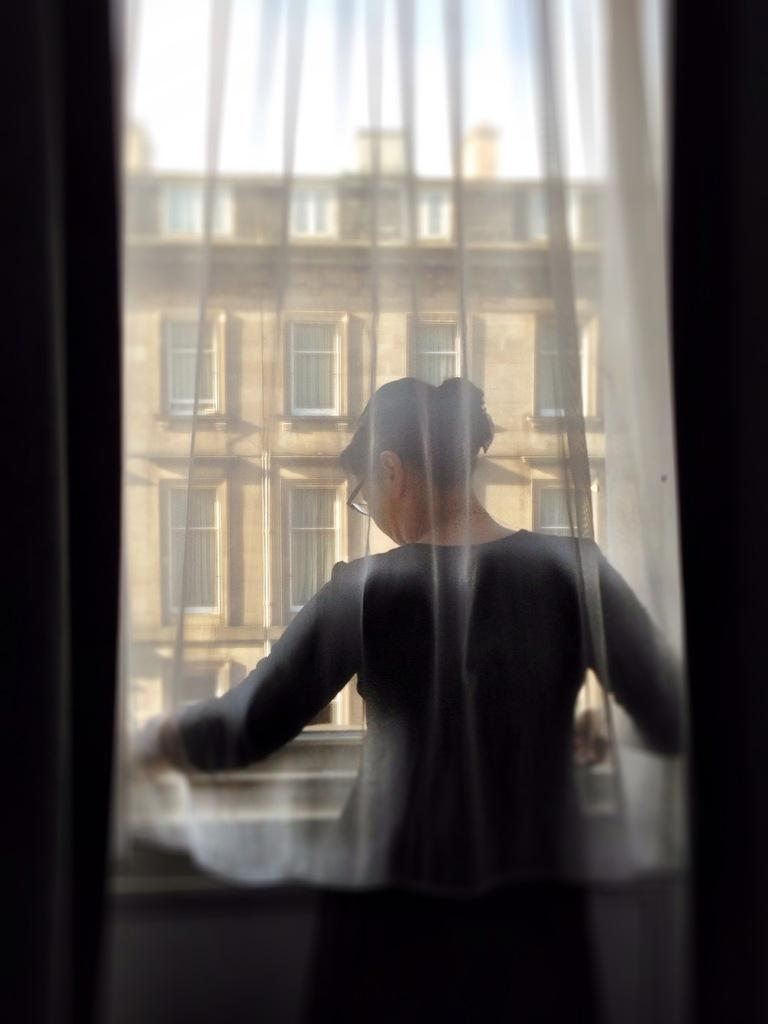Who or what is the main subject in the image? There is a person in the image. Where is the person located in relation to other elements in the image? The person is in front of a window. What can be seen in the middle of the image? There is a building in the middle of the image. Where is the sink located in the image? There is no sink present in the image. What type of science experiment is being conducted in the image? There is no science experiment or reference to science in the image. 